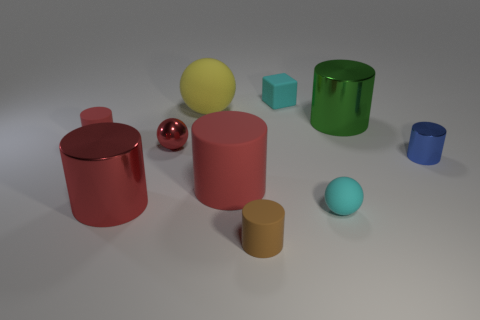What objects are present in the image and what are their colors? The image features a variety of geometric objects including two cylinders, one red and one cyan; a red sphere; a green metallic cylinder; a small pink sphere; a yellow sphere; a brown cylinder; and two cubes, one light blue and one blue. 